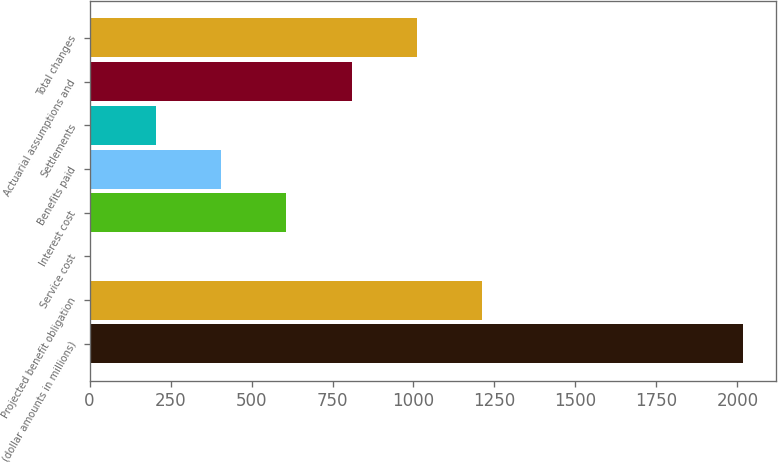Convert chart. <chart><loc_0><loc_0><loc_500><loc_500><bar_chart><fcel>(dollar amounts in millions)<fcel>Projected benefit obligation<fcel>Service cost<fcel>Interest cost<fcel>Benefits paid<fcel>Settlements<fcel>Actuarial assumptions and<fcel>Total changes<nl><fcel>2018<fcel>1212<fcel>3<fcel>607.5<fcel>406<fcel>204.5<fcel>809<fcel>1010.5<nl></chart> 